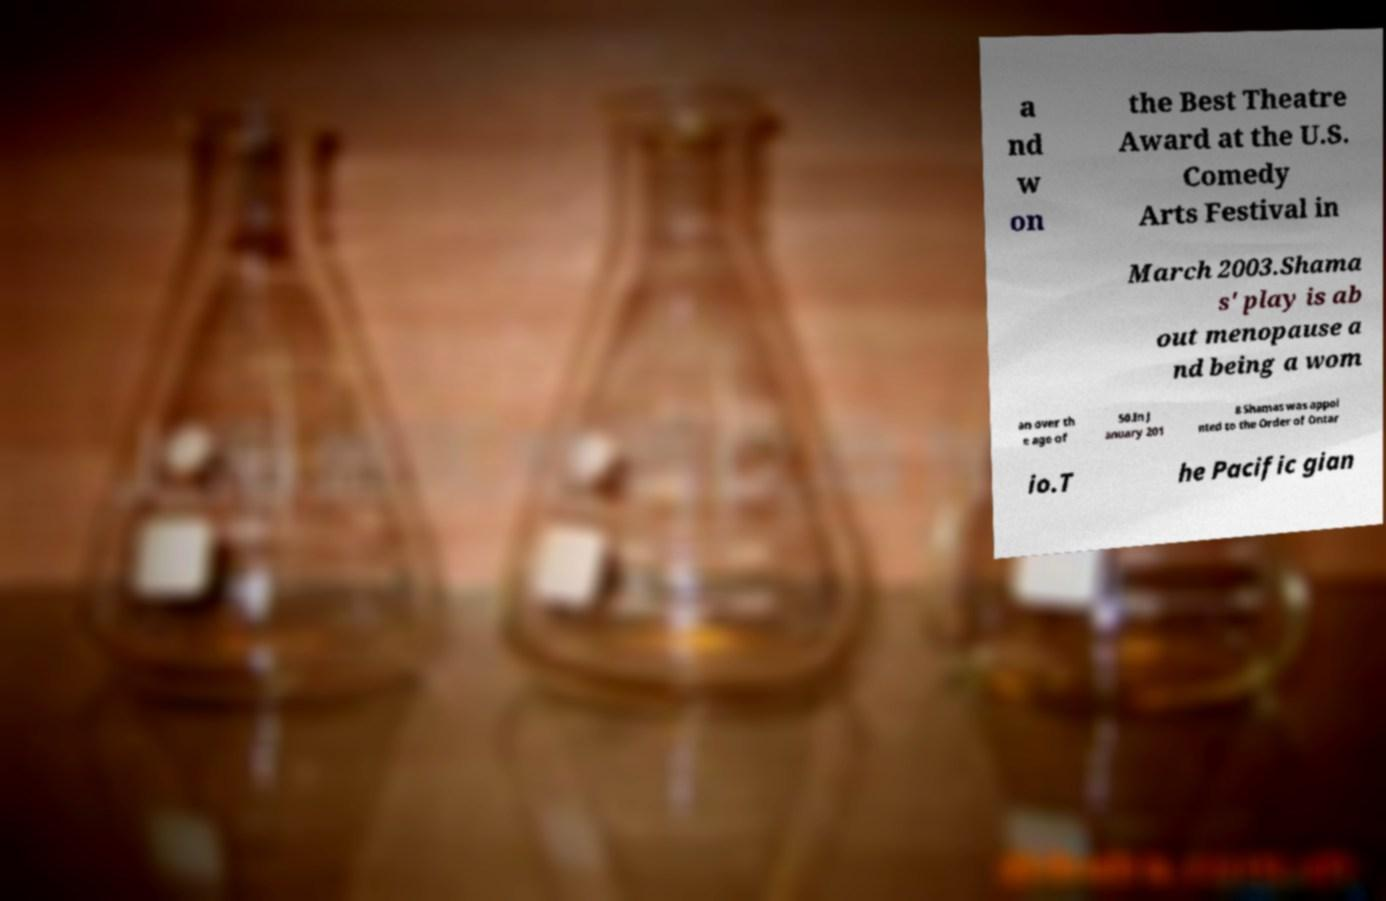There's text embedded in this image that I need extracted. Can you transcribe it verbatim? a nd w on the Best Theatre Award at the U.S. Comedy Arts Festival in March 2003.Shama s' play is ab out menopause a nd being a wom an over th e age of 50.In J anuary 201 8 Shamas was appoi nted to the Order of Ontar io.T he Pacific gian 